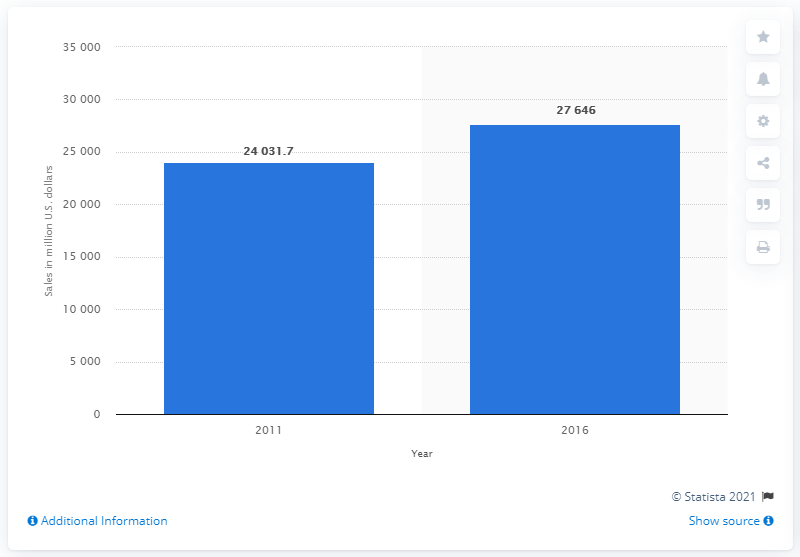Identify some key points in this picture. In the year 2011, dollar stores reached a total of 24.03 billion dollars in sales. In 2011, the estimated worth of dollar stores was 24,031.7 million dollars. 